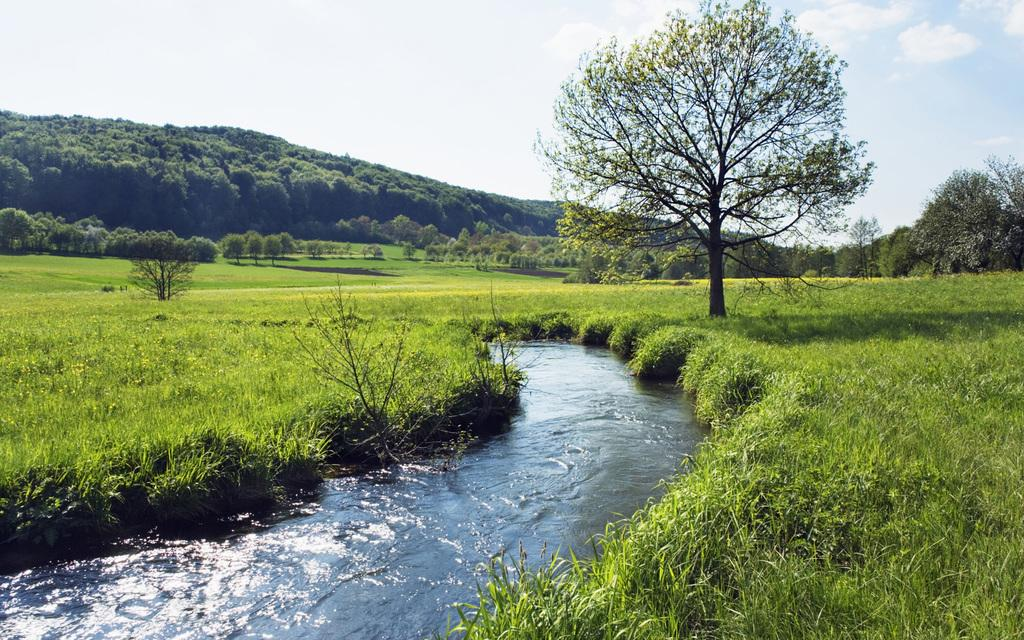What is one of the natural elements present in the image? There is water in the image. What type of vegetation can be seen in the image? There is grass and trees in the image. What geographical feature is visible in the image? There is a hill in the image. What can be seen in the background of the image? The sky is visible in the background of the image. What type of smell can be detected from the arm in the image? There is no arm present in the image, so it is not possible to detect any smell. 